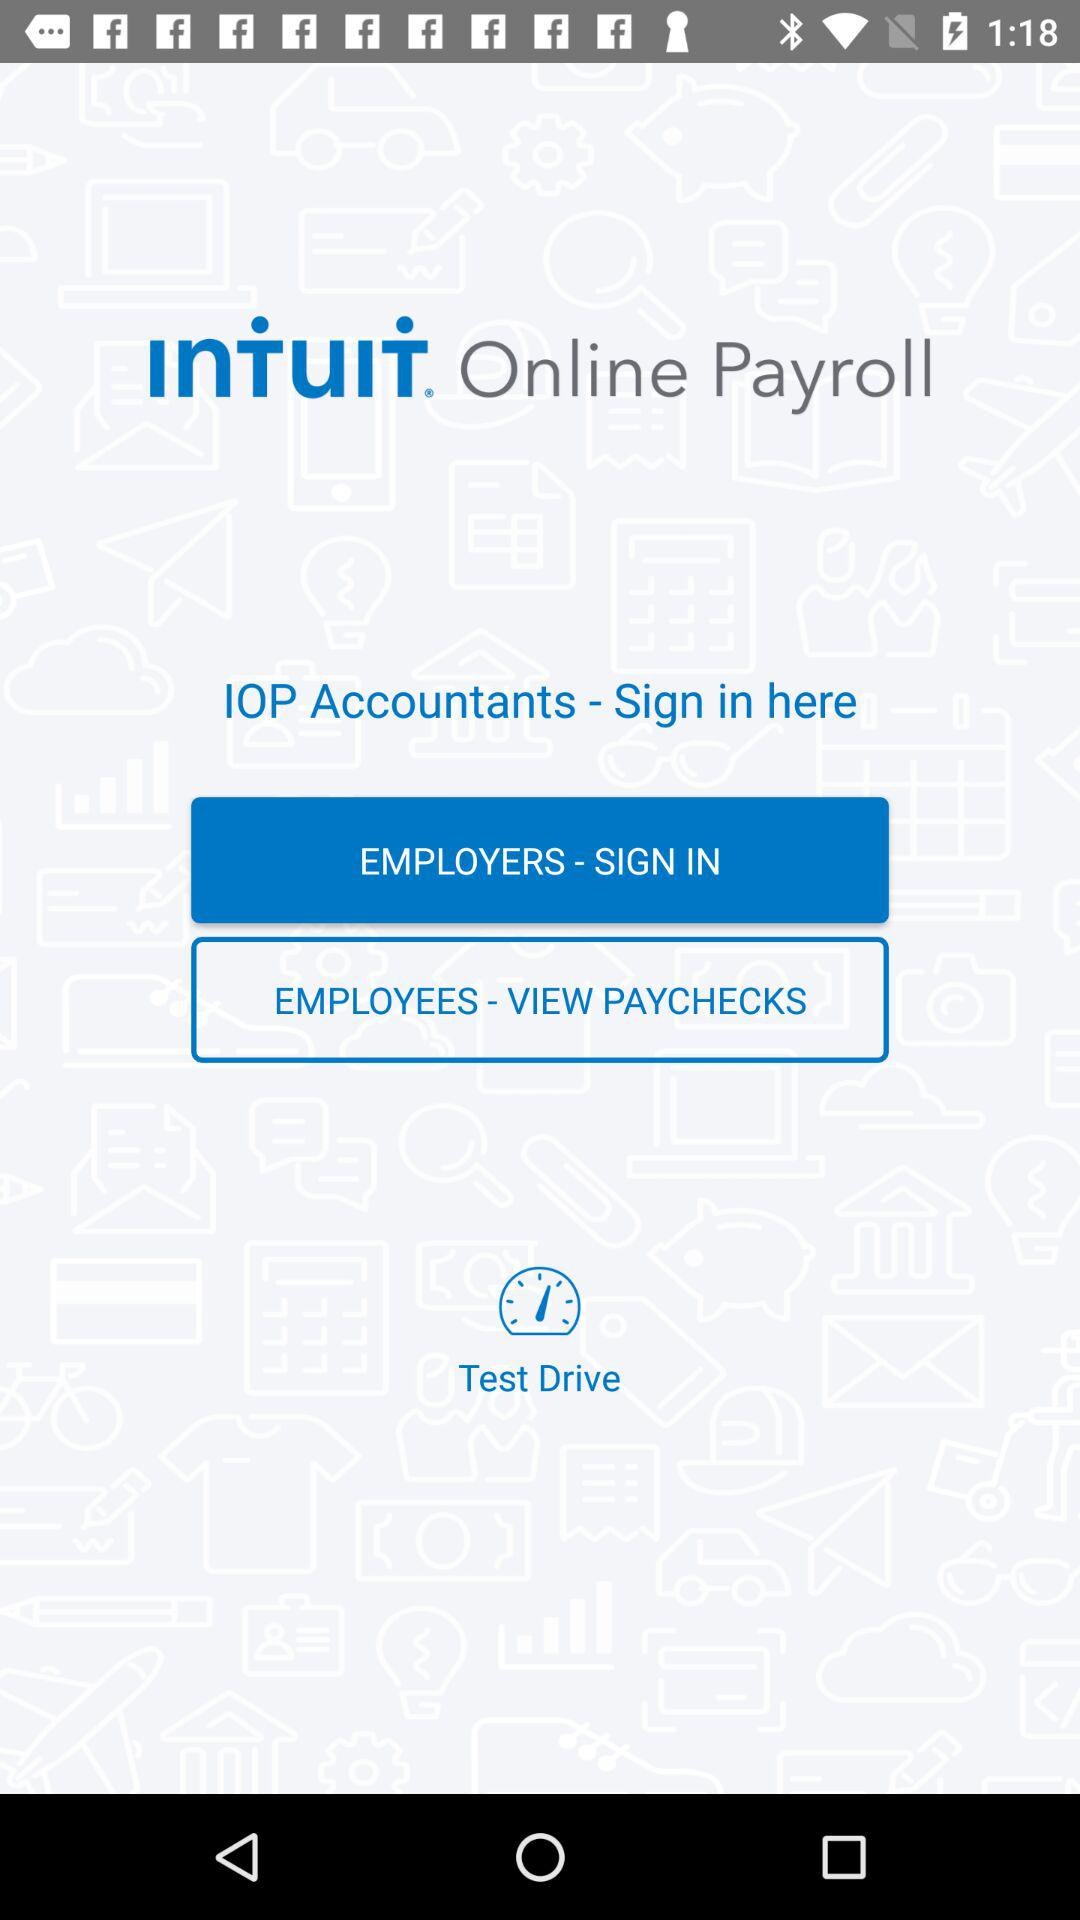What is the selected option? The selected option is "EMPLOYERS - SIGN IN". 